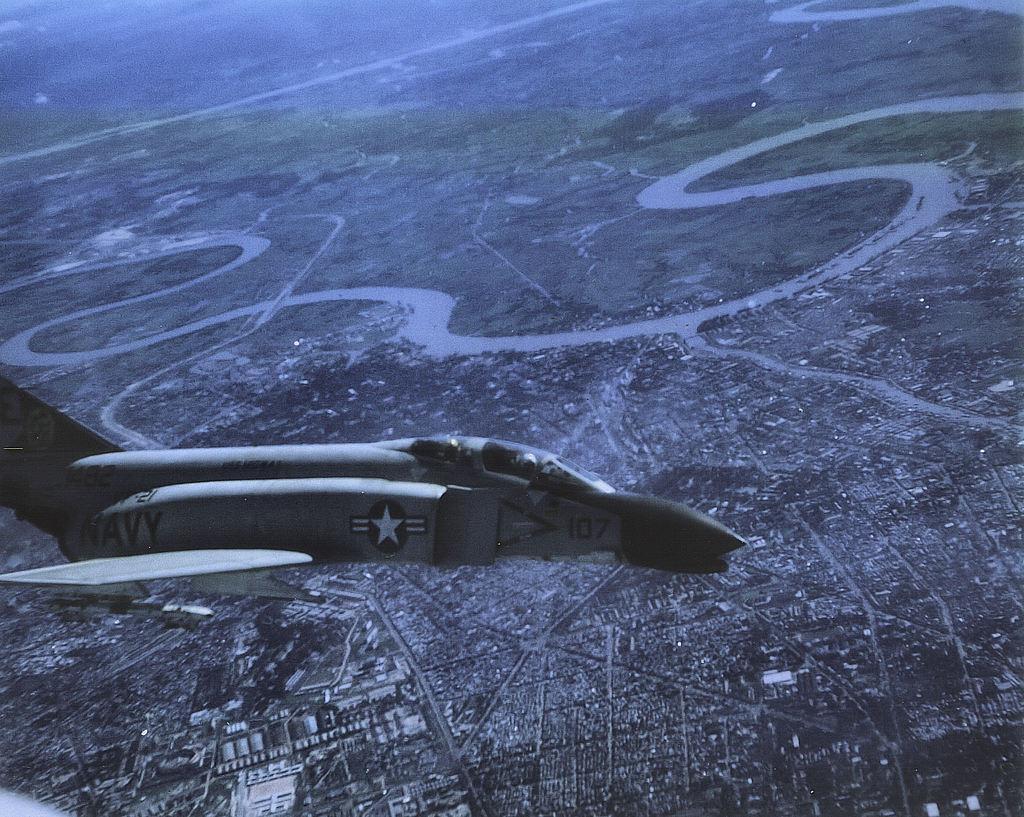Can you describe this image briefly? In this picture, we see an airplane which is in grey color. At the bottom of the picture, we see many buildings and trees in the city. In the background, we see the road and this is the top view of the city. 